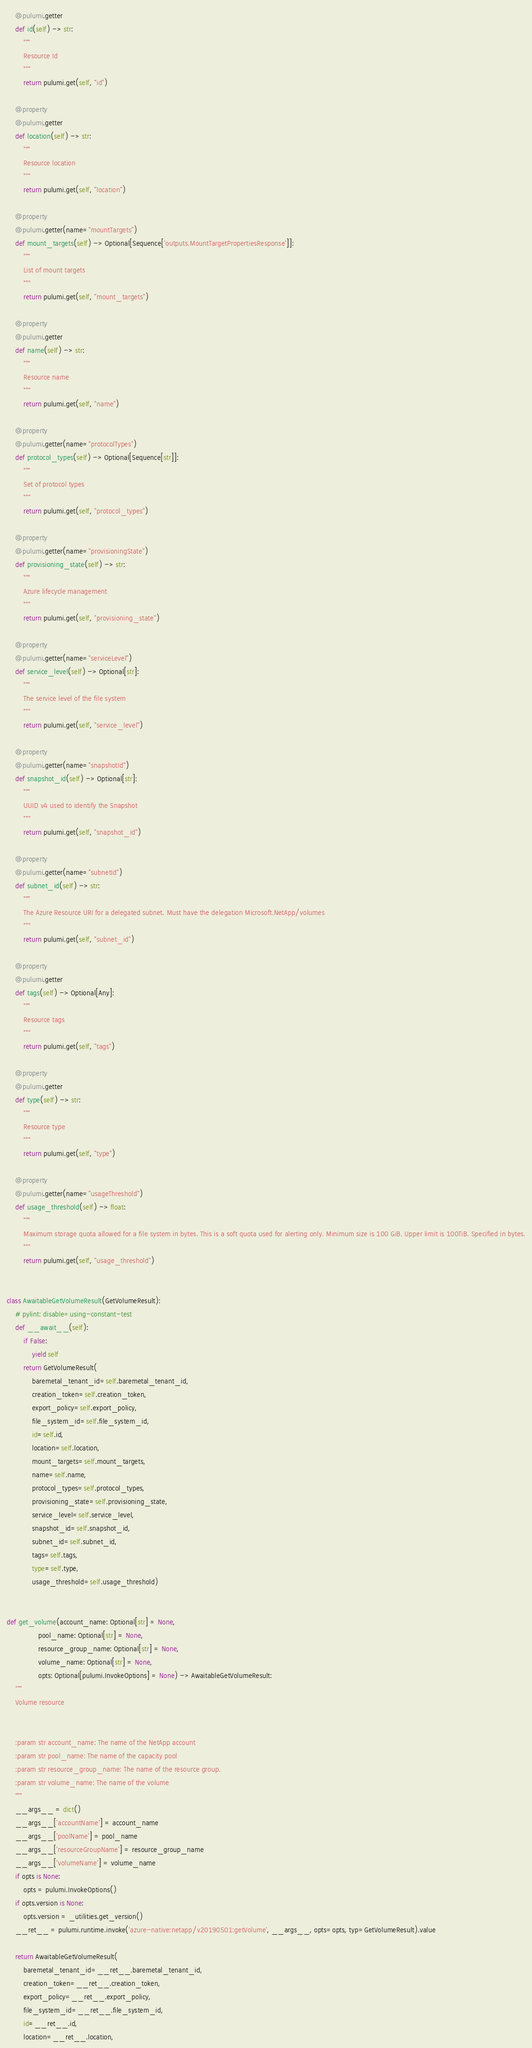<code> <loc_0><loc_0><loc_500><loc_500><_Python_>    @pulumi.getter
    def id(self) -> str:
        """
        Resource Id
        """
        return pulumi.get(self, "id")

    @property
    @pulumi.getter
    def location(self) -> str:
        """
        Resource location
        """
        return pulumi.get(self, "location")

    @property
    @pulumi.getter(name="mountTargets")
    def mount_targets(self) -> Optional[Sequence['outputs.MountTargetPropertiesResponse']]:
        """
        List of mount targets
        """
        return pulumi.get(self, "mount_targets")

    @property
    @pulumi.getter
    def name(self) -> str:
        """
        Resource name
        """
        return pulumi.get(self, "name")

    @property
    @pulumi.getter(name="protocolTypes")
    def protocol_types(self) -> Optional[Sequence[str]]:
        """
        Set of protocol types
        """
        return pulumi.get(self, "protocol_types")

    @property
    @pulumi.getter(name="provisioningState")
    def provisioning_state(self) -> str:
        """
        Azure lifecycle management
        """
        return pulumi.get(self, "provisioning_state")

    @property
    @pulumi.getter(name="serviceLevel")
    def service_level(self) -> Optional[str]:
        """
        The service level of the file system
        """
        return pulumi.get(self, "service_level")

    @property
    @pulumi.getter(name="snapshotId")
    def snapshot_id(self) -> Optional[str]:
        """
        UUID v4 used to identify the Snapshot
        """
        return pulumi.get(self, "snapshot_id")

    @property
    @pulumi.getter(name="subnetId")
    def subnet_id(self) -> str:
        """
        The Azure Resource URI for a delegated subnet. Must have the delegation Microsoft.NetApp/volumes
        """
        return pulumi.get(self, "subnet_id")

    @property
    @pulumi.getter
    def tags(self) -> Optional[Any]:
        """
        Resource tags
        """
        return pulumi.get(self, "tags")

    @property
    @pulumi.getter
    def type(self) -> str:
        """
        Resource type
        """
        return pulumi.get(self, "type")

    @property
    @pulumi.getter(name="usageThreshold")
    def usage_threshold(self) -> float:
        """
        Maximum storage quota allowed for a file system in bytes. This is a soft quota used for alerting only. Minimum size is 100 GiB. Upper limit is 100TiB. Specified in bytes.
        """
        return pulumi.get(self, "usage_threshold")


class AwaitableGetVolumeResult(GetVolumeResult):
    # pylint: disable=using-constant-test
    def __await__(self):
        if False:
            yield self
        return GetVolumeResult(
            baremetal_tenant_id=self.baremetal_tenant_id,
            creation_token=self.creation_token,
            export_policy=self.export_policy,
            file_system_id=self.file_system_id,
            id=self.id,
            location=self.location,
            mount_targets=self.mount_targets,
            name=self.name,
            protocol_types=self.protocol_types,
            provisioning_state=self.provisioning_state,
            service_level=self.service_level,
            snapshot_id=self.snapshot_id,
            subnet_id=self.subnet_id,
            tags=self.tags,
            type=self.type,
            usage_threshold=self.usage_threshold)


def get_volume(account_name: Optional[str] = None,
               pool_name: Optional[str] = None,
               resource_group_name: Optional[str] = None,
               volume_name: Optional[str] = None,
               opts: Optional[pulumi.InvokeOptions] = None) -> AwaitableGetVolumeResult:
    """
    Volume resource


    :param str account_name: The name of the NetApp account
    :param str pool_name: The name of the capacity pool
    :param str resource_group_name: The name of the resource group.
    :param str volume_name: The name of the volume
    """
    __args__ = dict()
    __args__['accountName'] = account_name
    __args__['poolName'] = pool_name
    __args__['resourceGroupName'] = resource_group_name
    __args__['volumeName'] = volume_name
    if opts is None:
        opts = pulumi.InvokeOptions()
    if opts.version is None:
        opts.version = _utilities.get_version()
    __ret__ = pulumi.runtime.invoke('azure-native:netapp/v20190501:getVolume', __args__, opts=opts, typ=GetVolumeResult).value

    return AwaitableGetVolumeResult(
        baremetal_tenant_id=__ret__.baremetal_tenant_id,
        creation_token=__ret__.creation_token,
        export_policy=__ret__.export_policy,
        file_system_id=__ret__.file_system_id,
        id=__ret__.id,
        location=__ret__.location,</code> 